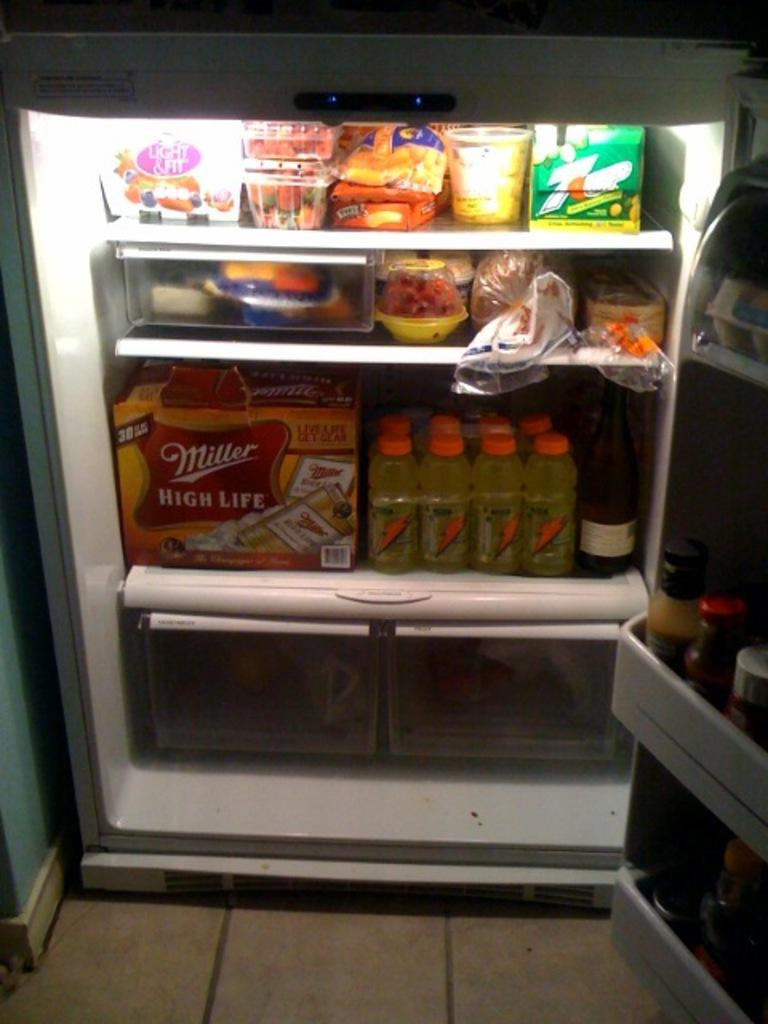What is the main object in the center of the image? There is a refrigerator in the center of the image. What types of items can be seen inside the refrigerator? There are bottles, boxes, tins, bowls, jars, and eggs visible in the refrigerator. Can you describe the contents of the refrigerator? The refrigerator contains food, as well as various containers and items. Where is the vase placed in the image? There is no vase present in the image. What type of record is being played in the background of the image? There is no record or music playing in the image; it only features a refrigerator and its contents. 